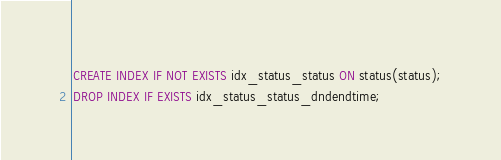<code> <loc_0><loc_0><loc_500><loc_500><_SQL_>CREATE INDEX IF NOT EXISTS idx_status_status ON status(status);
DROP INDEX IF EXISTS idx_status_status_dndendtime;
</code> 